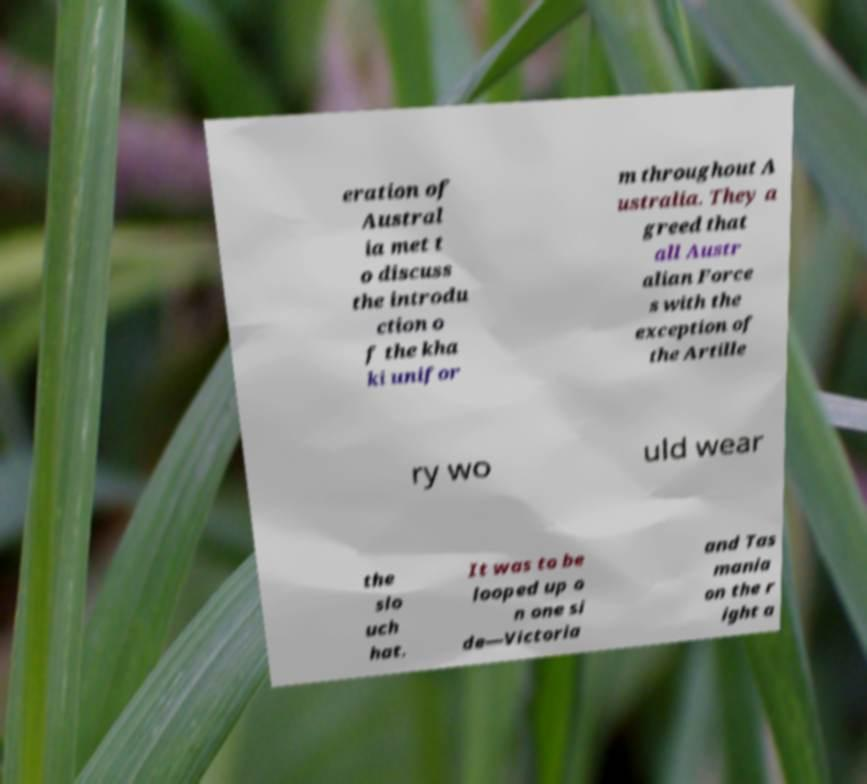Can you accurately transcribe the text from the provided image for me? eration of Austral ia met t o discuss the introdu ction o f the kha ki unifor m throughout A ustralia. They a greed that all Austr alian Force s with the exception of the Artille ry wo uld wear the slo uch hat. It was to be looped up o n one si de—Victoria and Tas mania on the r ight a 